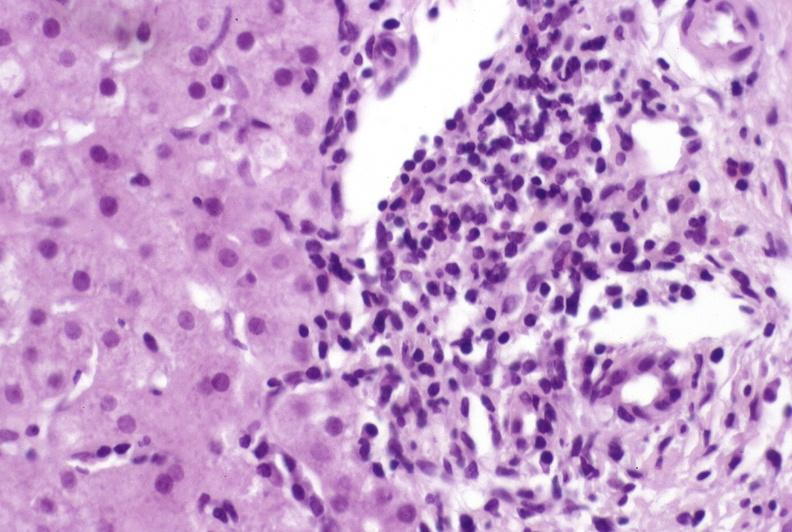s liver present?
Answer the question using a single word or phrase. Yes 